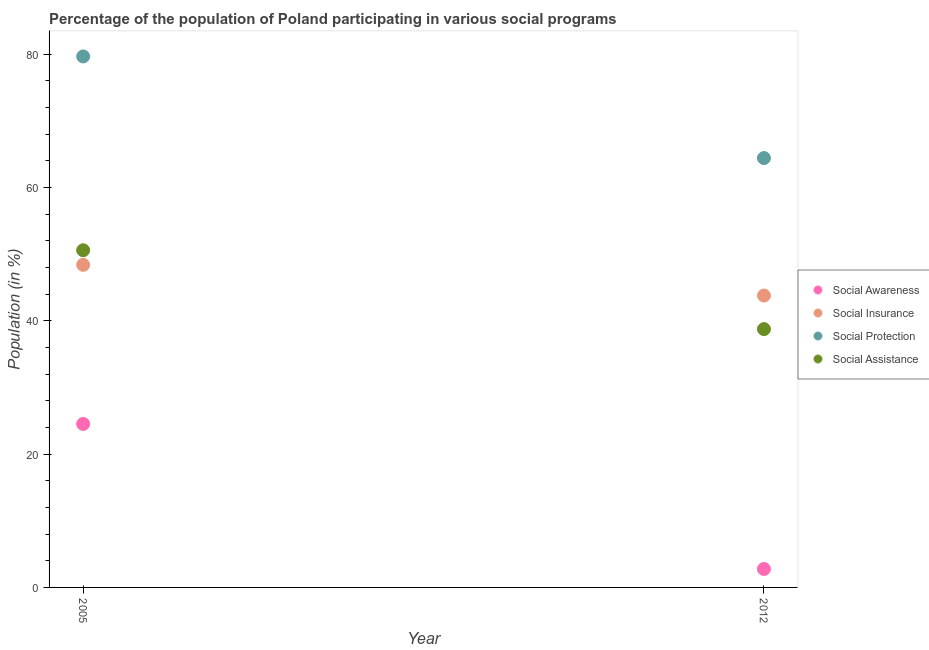How many different coloured dotlines are there?
Make the answer very short. 4. What is the participation of population in social awareness programs in 2005?
Offer a very short reply. 24.53. Across all years, what is the maximum participation of population in social insurance programs?
Provide a short and direct response. 48.4. Across all years, what is the minimum participation of population in social awareness programs?
Your answer should be compact. 2.77. In which year was the participation of population in social assistance programs maximum?
Provide a short and direct response. 2005. What is the total participation of population in social protection programs in the graph?
Keep it short and to the point. 144.07. What is the difference between the participation of population in social insurance programs in 2005 and that in 2012?
Your answer should be compact. 4.61. What is the difference between the participation of population in social protection programs in 2012 and the participation of population in social awareness programs in 2005?
Make the answer very short. 39.89. What is the average participation of population in social insurance programs per year?
Your answer should be compact. 46.09. In the year 2012, what is the difference between the participation of population in social awareness programs and participation of population in social assistance programs?
Ensure brevity in your answer.  -35.99. In how many years, is the participation of population in social assistance programs greater than 4 %?
Make the answer very short. 2. What is the ratio of the participation of population in social protection programs in 2005 to that in 2012?
Provide a short and direct response. 1.24. Is the participation of population in social insurance programs in 2005 less than that in 2012?
Give a very brief answer. No. Is it the case that in every year, the sum of the participation of population in social awareness programs and participation of population in social protection programs is greater than the sum of participation of population in social assistance programs and participation of population in social insurance programs?
Your answer should be very brief. No. Is it the case that in every year, the sum of the participation of population in social awareness programs and participation of population in social insurance programs is greater than the participation of population in social protection programs?
Make the answer very short. No. How many dotlines are there?
Provide a short and direct response. 4. How many years are there in the graph?
Offer a very short reply. 2. Are the values on the major ticks of Y-axis written in scientific E-notation?
Ensure brevity in your answer.  No. Does the graph contain any zero values?
Ensure brevity in your answer.  No. Does the graph contain grids?
Ensure brevity in your answer.  No. How are the legend labels stacked?
Your answer should be compact. Vertical. What is the title of the graph?
Provide a short and direct response. Percentage of the population of Poland participating in various social programs . What is the Population (in %) in Social Awareness in 2005?
Keep it short and to the point. 24.53. What is the Population (in %) of Social Insurance in 2005?
Keep it short and to the point. 48.4. What is the Population (in %) of Social Protection in 2005?
Provide a short and direct response. 79.66. What is the Population (in %) of Social Assistance in 2005?
Make the answer very short. 50.58. What is the Population (in %) in Social Awareness in 2012?
Your answer should be compact. 2.77. What is the Population (in %) in Social Insurance in 2012?
Your answer should be very brief. 43.79. What is the Population (in %) in Social Protection in 2012?
Your answer should be very brief. 64.41. What is the Population (in %) of Social Assistance in 2012?
Offer a terse response. 38.75. Across all years, what is the maximum Population (in %) of Social Awareness?
Keep it short and to the point. 24.53. Across all years, what is the maximum Population (in %) in Social Insurance?
Provide a succinct answer. 48.4. Across all years, what is the maximum Population (in %) of Social Protection?
Make the answer very short. 79.66. Across all years, what is the maximum Population (in %) of Social Assistance?
Offer a very short reply. 50.58. Across all years, what is the minimum Population (in %) in Social Awareness?
Your response must be concise. 2.77. Across all years, what is the minimum Population (in %) in Social Insurance?
Make the answer very short. 43.79. Across all years, what is the minimum Population (in %) in Social Protection?
Provide a short and direct response. 64.41. Across all years, what is the minimum Population (in %) in Social Assistance?
Offer a terse response. 38.75. What is the total Population (in %) of Social Awareness in the graph?
Make the answer very short. 27.29. What is the total Population (in %) in Social Insurance in the graph?
Make the answer very short. 92.19. What is the total Population (in %) of Social Protection in the graph?
Your answer should be very brief. 144.07. What is the total Population (in %) of Social Assistance in the graph?
Keep it short and to the point. 89.34. What is the difference between the Population (in %) in Social Awareness in 2005 and that in 2012?
Provide a short and direct response. 21.76. What is the difference between the Population (in %) in Social Insurance in 2005 and that in 2012?
Your response must be concise. 4.61. What is the difference between the Population (in %) of Social Protection in 2005 and that in 2012?
Make the answer very short. 15.24. What is the difference between the Population (in %) of Social Assistance in 2005 and that in 2012?
Keep it short and to the point. 11.83. What is the difference between the Population (in %) of Social Awareness in 2005 and the Population (in %) of Social Insurance in 2012?
Your response must be concise. -19.26. What is the difference between the Population (in %) in Social Awareness in 2005 and the Population (in %) in Social Protection in 2012?
Ensure brevity in your answer.  -39.89. What is the difference between the Population (in %) in Social Awareness in 2005 and the Population (in %) in Social Assistance in 2012?
Your answer should be very brief. -14.23. What is the difference between the Population (in %) in Social Insurance in 2005 and the Population (in %) in Social Protection in 2012?
Your response must be concise. -16.02. What is the difference between the Population (in %) of Social Insurance in 2005 and the Population (in %) of Social Assistance in 2012?
Keep it short and to the point. 9.65. What is the difference between the Population (in %) of Social Protection in 2005 and the Population (in %) of Social Assistance in 2012?
Offer a terse response. 40.91. What is the average Population (in %) in Social Awareness per year?
Offer a terse response. 13.65. What is the average Population (in %) of Social Insurance per year?
Offer a very short reply. 46.09. What is the average Population (in %) in Social Protection per year?
Provide a short and direct response. 72.04. What is the average Population (in %) in Social Assistance per year?
Offer a very short reply. 44.67. In the year 2005, what is the difference between the Population (in %) of Social Awareness and Population (in %) of Social Insurance?
Your answer should be very brief. -23.87. In the year 2005, what is the difference between the Population (in %) in Social Awareness and Population (in %) in Social Protection?
Your answer should be compact. -55.13. In the year 2005, what is the difference between the Population (in %) in Social Awareness and Population (in %) in Social Assistance?
Provide a short and direct response. -26.06. In the year 2005, what is the difference between the Population (in %) of Social Insurance and Population (in %) of Social Protection?
Make the answer very short. -31.26. In the year 2005, what is the difference between the Population (in %) in Social Insurance and Population (in %) in Social Assistance?
Give a very brief answer. -2.18. In the year 2005, what is the difference between the Population (in %) in Social Protection and Population (in %) in Social Assistance?
Provide a short and direct response. 29.08. In the year 2012, what is the difference between the Population (in %) in Social Awareness and Population (in %) in Social Insurance?
Offer a very short reply. -41.02. In the year 2012, what is the difference between the Population (in %) of Social Awareness and Population (in %) of Social Protection?
Your answer should be compact. -61.65. In the year 2012, what is the difference between the Population (in %) of Social Awareness and Population (in %) of Social Assistance?
Offer a very short reply. -35.99. In the year 2012, what is the difference between the Population (in %) in Social Insurance and Population (in %) in Social Protection?
Make the answer very short. -20.63. In the year 2012, what is the difference between the Population (in %) of Social Insurance and Population (in %) of Social Assistance?
Offer a terse response. 5.04. In the year 2012, what is the difference between the Population (in %) of Social Protection and Population (in %) of Social Assistance?
Your answer should be very brief. 25.66. What is the ratio of the Population (in %) in Social Awareness in 2005 to that in 2012?
Offer a very short reply. 8.87. What is the ratio of the Population (in %) in Social Insurance in 2005 to that in 2012?
Offer a terse response. 1.11. What is the ratio of the Population (in %) of Social Protection in 2005 to that in 2012?
Your answer should be compact. 1.24. What is the ratio of the Population (in %) of Social Assistance in 2005 to that in 2012?
Make the answer very short. 1.31. What is the difference between the highest and the second highest Population (in %) of Social Awareness?
Your response must be concise. 21.76. What is the difference between the highest and the second highest Population (in %) in Social Insurance?
Your response must be concise. 4.61. What is the difference between the highest and the second highest Population (in %) in Social Protection?
Give a very brief answer. 15.24. What is the difference between the highest and the second highest Population (in %) in Social Assistance?
Provide a succinct answer. 11.83. What is the difference between the highest and the lowest Population (in %) in Social Awareness?
Offer a terse response. 21.76. What is the difference between the highest and the lowest Population (in %) of Social Insurance?
Make the answer very short. 4.61. What is the difference between the highest and the lowest Population (in %) of Social Protection?
Give a very brief answer. 15.24. What is the difference between the highest and the lowest Population (in %) in Social Assistance?
Your answer should be very brief. 11.83. 